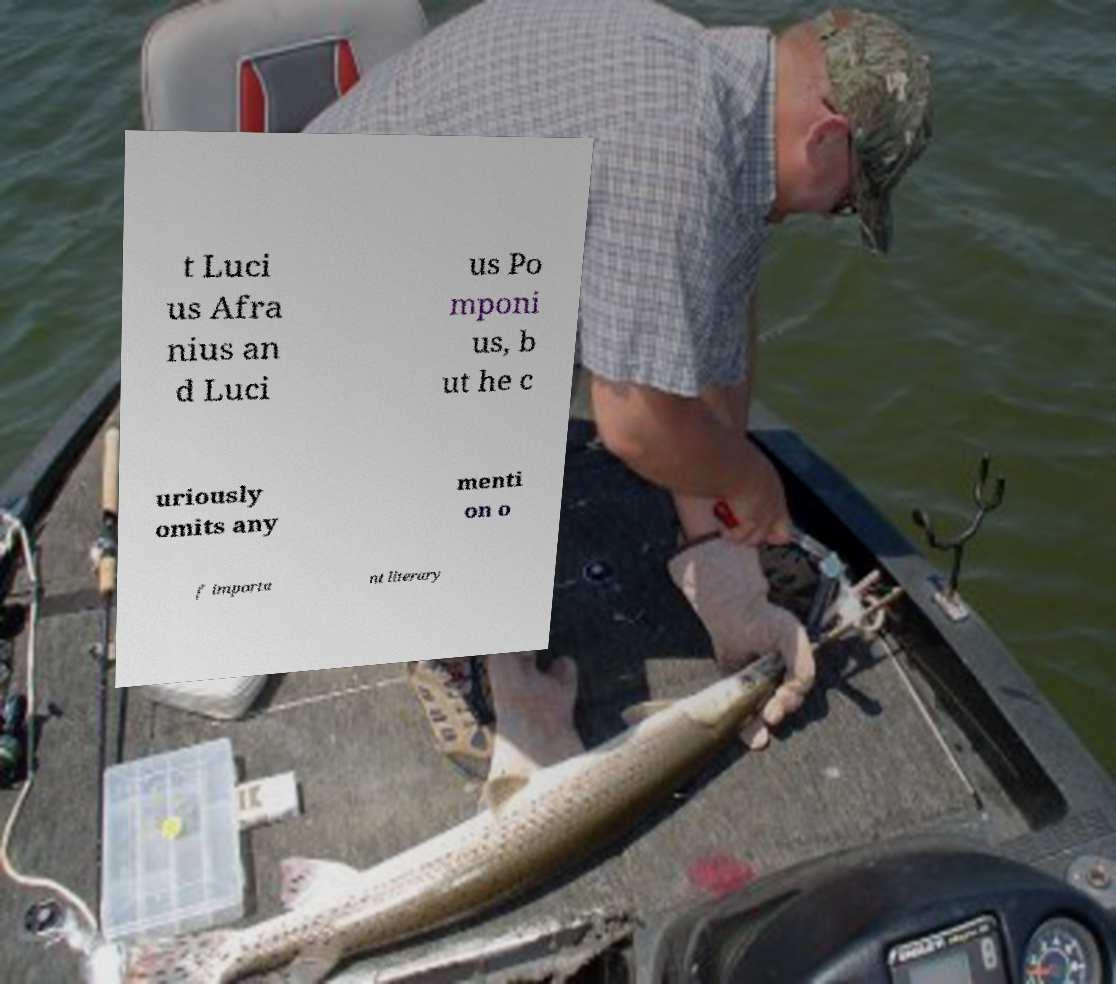For documentation purposes, I need the text within this image transcribed. Could you provide that? t Luci us Afra nius an d Luci us Po mponi us, b ut he c uriously omits any menti on o f importa nt literary 